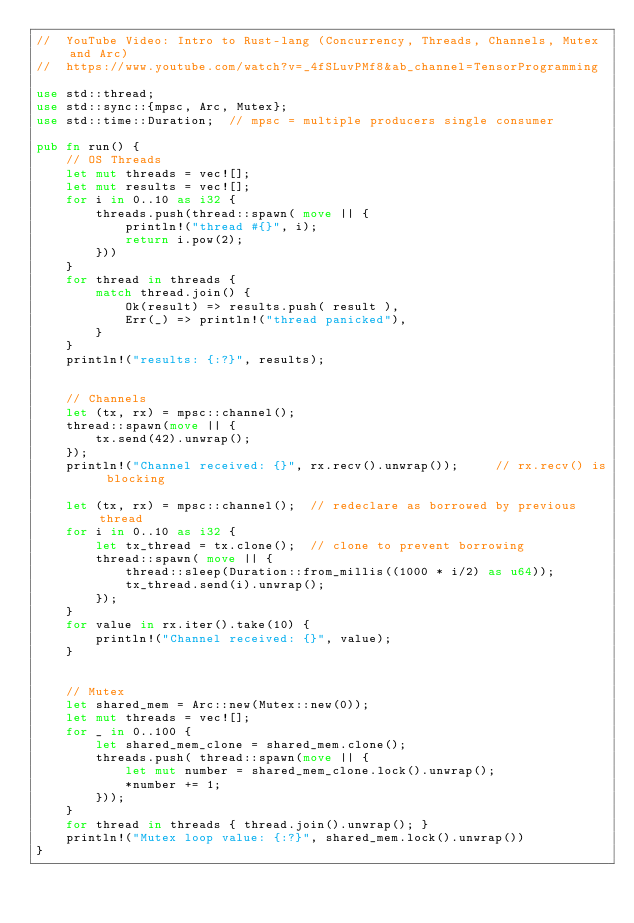<code> <loc_0><loc_0><loc_500><loc_500><_Rust_>//  YouTube Video: Intro to Rust-lang (Concurrency, Threads, Channels, Mutex and Arc)
//  https://www.youtube.com/watch?v=_4fSLuvPMf8&ab_channel=TensorProgramming

use std::thread;
use std::sync::{mpsc, Arc, Mutex};
use std::time::Duration;  // mpsc = multiple producers single consumer

pub fn run() {
    // OS Threads
    let mut threads = vec![];
    let mut results = vec![];
    for i in 0..10 as i32 {
        threads.push(thread::spawn( move || {
            println!("thread #{}", i);
            return i.pow(2);
        }))
    }
    for thread in threads {
        match thread.join() {
            Ok(result) => results.push( result ),
            Err(_) => println!("thread panicked"),
        }
    }
    println!("results: {:?}", results);


    // Channels
    let (tx, rx) = mpsc::channel();
    thread::spawn(move || {
        tx.send(42).unwrap();
    });
    println!("Channel received: {}", rx.recv().unwrap());     // rx.recv() is blocking

    let (tx, rx) = mpsc::channel();  // redeclare as borrowed by previous thread
    for i in 0..10 as i32 {
        let tx_thread = tx.clone();  // clone to prevent borrowing
        thread::spawn( move || {
            thread::sleep(Duration::from_millis((1000 * i/2) as u64));
            tx_thread.send(i).unwrap();
        });
    }
    for value in rx.iter().take(10) {
        println!("Channel received: {}", value);
    }


    // Mutex
    let shared_mem = Arc::new(Mutex::new(0));
    let mut threads = vec![];
    for _ in 0..100 {
        let shared_mem_clone = shared_mem.clone();
        threads.push( thread::spawn(move || {
            let mut number = shared_mem_clone.lock().unwrap();
            *number += 1;
        }));
    }
    for thread in threads { thread.join().unwrap(); }
    println!("Mutex loop value: {:?}", shared_mem.lock().unwrap())
}</code> 